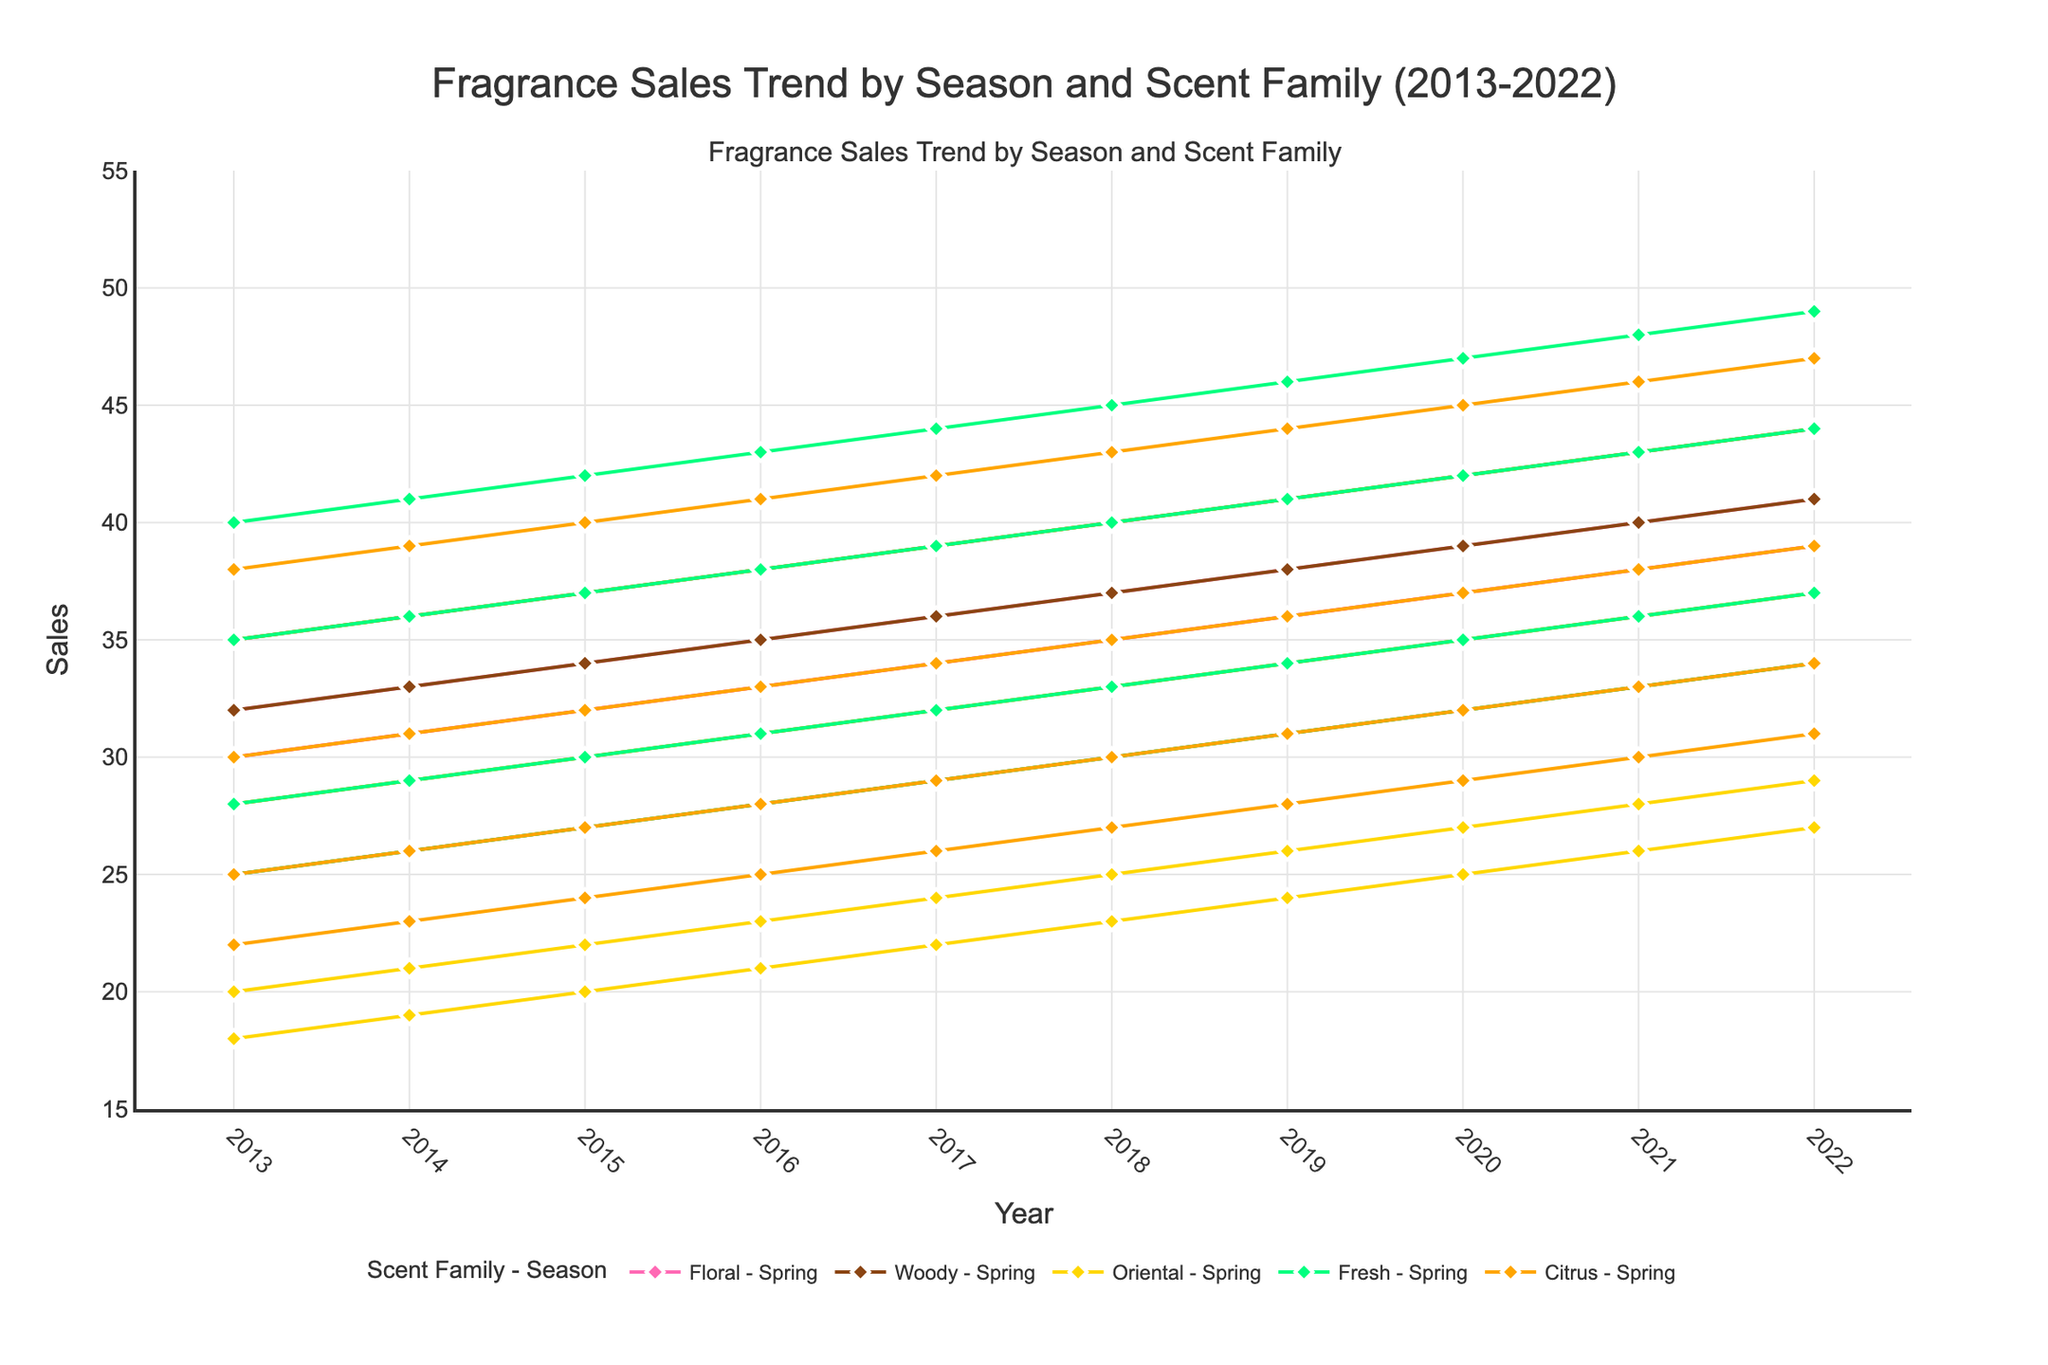Which scent family has the highest sales in Summer 2022? Look at the data points for each scent family in Summer 2022. The highest value is for Fresh with a sales value of 49.
Answer: Fresh During which seasons from 2013 to 2022 does the Woody scent family have the highest sales? Compare the sales of the Woody scent family across all seasons for the period 2013 to 2022. The highest values appear in Winter, consistently across the years.
Answer: Winter What is the average sales of the Citrus scent family in Fall from 2013 to 2022? Sum the sales values for the Citrus scent family in Fall, then divide by the number of years (10): (25+26+27+28+29+30+31+32+33+34)/10 = 295/10 = 29.5.
Answer: 29.5 Which scent family showed the most consistent sales trend across all seasons over the decade? Examine the line trends of each scent family. The Woody scent shows relatively stable increases without drastic changes, indicating a consistent trend.
Answer: Woody In which year did the Floral scent family have the highest sales in Spring, and what is the value? Review the data for Floral sales in Spring across the years. The highest value is in 2022 with a sales value of 41.
Answer: 2022, 41 How do the sales of the Oriental scent family in Winter 2017 compare to Winter 2020? Look at the Oriental sales data for Winter in 2017 and 2020. The sales were 39 in 2017, and 42 in 2020, showing an increase.
Answer: Increased from 39 to 42 What is the total sales of the Fresh scent family in Summer from 2013 to 2022? Sum the sales values for Fresh in Summer across the years: 40+41+42+43+44+45+46+47+48+49 = 445.
Answer: 445 Which season shows the highest variability in sales for the Citrus scent family over the decade? Examine the range of the Citrus sales across the seasons by finding the difference between the highest and lowest values for each season. Winter shows the highest range from 22 to 31, a variability of 9.
Answer: Winter 